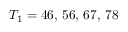Convert formula to latex. <formula><loc_0><loc_0><loc_500><loc_500>T _ { 1 } = 4 6 , \, 5 6 , \, 6 7 , \, 7 8</formula> 